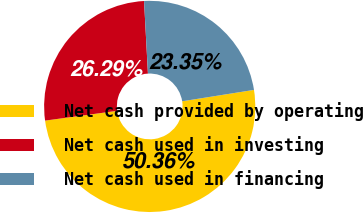Convert chart to OTSL. <chart><loc_0><loc_0><loc_500><loc_500><pie_chart><fcel>Net cash provided by operating<fcel>Net cash used in investing<fcel>Net cash used in financing<nl><fcel>50.36%<fcel>26.29%<fcel>23.35%<nl></chart> 